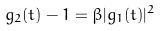<formula> <loc_0><loc_0><loc_500><loc_500>g _ { 2 } ( t ) - 1 = \beta | g _ { 1 } ( t ) | ^ { 2 }</formula> 